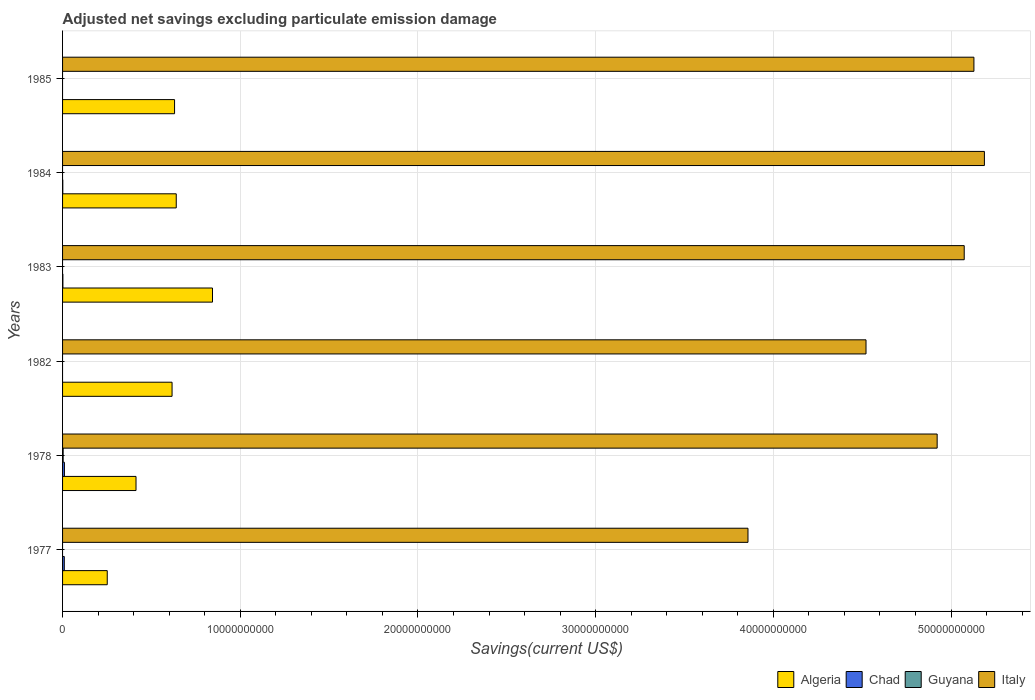How many different coloured bars are there?
Provide a succinct answer. 4. Are the number of bars per tick equal to the number of legend labels?
Provide a short and direct response. No. Are the number of bars on each tick of the Y-axis equal?
Ensure brevity in your answer.  No. How many bars are there on the 2nd tick from the top?
Offer a very short reply. 3. What is the adjusted net savings in Chad in 1984?
Ensure brevity in your answer.  1.26e+07. Across all years, what is the maximum adjusted net savings in Chad?
Keep it short and to the point. 1.05e+08. Across all years, what is the minimum adjusted net savings in Algeria?
Keep it short and to the point. 2.51e+09. In which year was the adjusted net savings in Italy maximum?
Make the answer very short. 1984. What is the total adjusted net savings in Chad in the graph?
Your answer should be very brief. 2.33e+08. What is the difference between the adjusted net savings in Italy in 1983 and that in 1984?
Your response must be concise. -1.14e+09. What is the difference between the adjusted net savings in Italy in 1978 and the adjusted net savings in Guyana in 1985?
Keep it short and to the point. 4.92e+1. What is the average adjusted net savings in Guyana per year?
Make the answer very short. 5.49e+06. In the year 1978, what is the difference between the adjusted net savings in Guyana and adjusted net savings in Italy?
Your answer should be compact. -4.92e+1. In how many years, is the adjusted net savings in Italy greater than 4000000000 US$?
Provide a short and direct response. 6. What is the ratio of the adjusted net savings in Italy in 1983 to that in 1984?
Provide a succinct answer. 0.98. What is the difference between the highest and the second highest adjusted net savings in Italy?
Keep it short and to the point. 5.90e+08. What is the difference between the highest and the lowest adjusted net savings in Algeria?
Offer a very short reply. 5.92e+09. Is the sum of the adjusted net savings in Chad in 1978 and 1984 greater than the maximum adjusted net savings in Italy across all years?
Keep it short and to the point. No. What is the difference between two consecutive major ticks on the X-axis?
Offer a terse response. 1.00e+1. Are the values on the major ticks of X-axis written in scientific E-notation?
Offer a very short reply. No. Does the graph contain grids?
Keep it short and to the point. Yes. How many legend labels are there?
Offer a terse response. 4. How are the legend labels stacked?
Make the answer very short. Horizontal. What is the title of the graph?
Make the answer very short. Adjusted net savings excluding particulate emission damage. What is the label or title of the X-axis?
Offer a very short reply. Savings(current US$). What is the Savings(current US$) in Algeria in 1977?
Ensure brevity in your answer.  2.51e+09. What is the Savings(current US$) of Chad in 1977?
Your answer should be very brief. 9.73e+07. What is the Savings(current US$) of Guyana in 1977?
Offer a very short reply. 0. What is the Savings(current US$) in Italy in 1977?
Your answer should be compact. 3.86e+1. What is the Savings(current US$) in Algeria in 1978?
Give a very brief answer. 4.13e+09. What is the Savings(current US$) in Chad in 1978?
Offer a very short reply. 1.05e+08. What is the Savings(current US$) of Guyana in 1978?
Keep it short and to the point. 3.29e+07. What is the Savings(current US$) of Italy in 1978?
Your response must be concise. 4.92e+1. What is the Savings(current US$) in Algeria in 1982?
Offer a terse response. 6.16e+09. What is the Savings(current US$) in Chad in 1982?
Your answer should be very brief. 0. What is the Savings(current US$) of Guyana in 1982?
Make the answer very short. 0. What is the Savings(current US$) of Italy in 1982?
Your response must be concise. 4.52e+1. What is the Savings(current US$) of Algeria in 1983?
Provide a succinct answer. 8.44e+09. What is the Savings(current US$) of Chad in 1983?
Ensure brevity in your answer.  1.84e+07. What is the Savings(current US$) in Italy in 1983?
Give a very brief answer. 5.07e+1. What is the Savings(current US$) of Algeria in 1984?
Offer a very short reply. 6.40e+09. What is the Savings(current US$) of Chad in 1984?
Offer a terse response. 1.26e+07. What is the Savings(current US$) of Guyana in 1984?
Your answer should be compact. 0. What is the Savings(current US$) in Italy in 1984?
Your response must be concise. 5.19e+1. What is the Savings(current US$) in Algeria in 1985?
Provide a short and direct response. 6.30e+09. What is the Savings(current US$) in Italy in 1985?
Ensure brevity in your answer.  5.13e+1. Across all years, what is the maximum Savings(current US$) in Algeria?
Ensure brevity in your answer.  8.44e+09. Across all years, what is the maximum Savings(current US$) of Chad?
Offer a terse response. 1.05e+08. Across all years, what is the maximum Savings(current US$) in Guyana?
Provide a succinct answer. 3.29e+07. Across all years, what is the maximum Savings(current US$) in Italy?
Ensure brevity in your answer.  5.19e+1. Across all years, what is the minimum Savings(current US$) of Algeria?
Provide a succinct answer. 2.51e+09. Across all years, what is the minimum Savings(current US$) of Italy?
Offer a terse response. 3.86e+1. What is the total Savings(current US$) of Algeria in the graph?
Offer a very short reply. 3.39e+1. What is the total Savings(current US$) of Chad in the graph?
Provide a succinct answer. 2.33e+08. What is the total Savings(current US$) in Guyana in the graph?
Keep it short and to the point. 3.29e+07. What is the total Savings(current US$) in Italy in the graph?
Your answer should be compact. 2.87e+11. What is the difference between the Savings(current US$) in Algeria in 1977 and that in 1978?
Your response must be concise. -1.62e+09. What is the difference between the Savings(current US$) of Chad in 1977 and that in 1978?
Your answer should be very brief. -7.54e+06. What is the difference between the Savings(current US$) of Italy in 1977 and that in 1978?
Offer a very short reply. -1.06e+1. What is the difference between the Savings(current US$) in Algeria in 1977 and that in 1982?
Your response must be concise. -3.65e+09. What is the difference between the Savings(current US$) of Italy in 1977 and that in 1982?
Provide a succinct answer. -6.64e+09. What is the difference between the Savings(current US$) of Algeria in 1977 and that in 1983?
Make the answer very short. -5.92e+09. What is the difference between the Savings(current US$) of Chad in 1977 and that in 1983?
Provide a short and direct response. 7.90e+07. What is the difference between the Savings(current US$) of Italy in 1977 and that in 1983?
Offer a very short reply. -1.22e+1. What is the difference between the Savings(current US$) of Algeria in 1977 and that in 1984?
Ensure brevity in your answer.  -3.88e+09. What is the difference between the Savings(current US$) of Chad in 1977 and that in 1984?
Ensure brevity in your answer.  8.47e+07. What is the difference between the Savings(current US$) in Italy in 1977 and that in 1984?
Your response must be concise. -1.33e+1. What is the difference between the Savings(current US$) of Algeria in 1977 and that in 1985?
Offer a very short reply. -3.79e+09. What is the difference between the Savings(current US$) of Italy in 1977 and that in 1985?
Provide a short and direct response. -1.27e+1. What is the difference between the Savings(current US$) in Algeria in 1978 and that in 1982?
Provide a succinct answer. -2.03e+09. What is the difference between the Savings(current US$) of Italy in 1978 and that in 1982?
Give a very brief answer. 4.00e+09. What is the difference between the Savings(current US$) of Algeria in 1978 and that in 1983?
Offer a terse response. -4.30e+09. What is the difference between the Savings(current US$) in Chad in 1978 and that in 1983?
Make the answer very short. 8.65e+07. What is the difference between the Savings(current US$) in Italy in 1978 and that in 1983?
Your answer should be very brief. -1.52e+09. What is the difference between the Savings(current US$) in Algeria in 1978 and that in 1984?
Provide a succinct answer. -2.26e+09. What is the difference between the Savings(current US$) in Chad in 1978 and that in 1984?
Offer a terse response. 9.23e+07. What is the difference between the Savings(current US$) in Italy in 1978 and that in 1984?
Provide a succinct answer. -2.66e+09. What is the difference between the Savings(current US$) in Algeria in 1978 and that in 1985?
Give a very brief answer. -2.17e+09. What is the difference between the Savings(current US$) of Italy in 1978 and that in 1985?
Your response must be concise. -2.07e+09. What is the difference between the Savings(current US$) in Algeria in 1982 and that in 1983?
Ensure brevity in your answer.  -2.28e+09. What is the difference between the Savings(current US$) in Italy in 1982 and that in 1983?
Offer a very short reply. -5.53e+09. What is the difference between the Savings(current US$) of Algeria in 1982 and that in 1984?
Keep it short and to the point. -2.36e+08. What is the difference between the Savings(current US$) of Italy in 1982 and that in 1984?
Your answer should be very brief. -6.66e+09. What is the difference between the Savings(current US$) of Algeria in 1982 and that in 1985?
Your answer should be compact. -1.40e+08. What is the difference between the Savings(current US$) in Italy in 1982 and that in 1985?
Your answer should be very brief. -6.07e+09. What is the difference between the Savings(current US$) of Algeria in 1983 and that in 1984?
Provide a short and direct response. 2.04e+09. What is the difference between the Savings(current US$) in Chad in 1983 and that in 1984?
Provide a short and direct response. 5.76e+06. What is the difference between the Savings(current US$) of Italy in 1983 and that in 1984?
Offer a terse response. -1.14e+09. What is the difference between the Savings(current US$) in Algeria in 1983 and that in 1985?
Your answer should be compact. 2.14e+09. What is the difference between the Savings(current US$) of Italy in 1983 and that in 1985?
Make the answer very short. -5.46e+08. What is the difference between the Savings(current US$) in Algeria in 1984 and that in 1985?
Your answer should be very brief. 9.57e+07. What is the difference between the Savings(current US$) of Italy in 1984 and that in 1985?
Offer a terse response. 5.90e+08. What is the difference between the Savings(current US$) in Algeria in 1977 and the Savings(current US$) in Chad in 1978?
Give a very brief answer. 2.41e+09. What is the difference between the Savings(current US$) in Algeria in 1977 and the Savings(current US$) in Guyana in 1978?
Give a very brief answer. 2.48e+09. What is the difference between the Savings(current US$) of Algeria in 1977 and the Savings(current US$) of Italy in 1978?
Ensure brevity in your answer.  -4.67e+1. What is the difference between the Savings(current US$) in Chad in 1977 and the Savings(current US$) in Guyana in 1978?
Keep it short and to the point. 6.44e+07. What is the difference between the Savings(current US$) in Chad in 1977 and the Savings(current US$) in Italy in 1978?
Keep it short and to the point. -4.91e+1. What is the difference between the Savings(current US$) of Algeria in 1977 and the Savings(current US$) of Italy in 1982?
Offer a terse response. -4.27e+1. What is the difference between the Savings(current US$) in Chad in 1977 and the Savings(current US$) in Italy in 1982?
Offer a terse response. -4.51e+1. What is the difference between the Savings(current US$) of Algeria in 1977 and the Savings(current US$) of Chad in 1983?
Provide a short and direct response. 2.50e+09. What is the difference between the Savings(current US$) of Algeria in 1977 and the Savings(current US$) of Italy in 1983?
Your answer should be compact. -4.82e+1. What is the difference between the Savings(current US$) of Chad in 1977 and the Savings(current US$) of Italy in 1983?
Give a very brief answer. -5.06e+1. What is the difference between the Savings(current US$) of Algeria in 1977 and the Savings(current US$) of Chad in 1984?
Provide a short and direct response. 2.50e+09. What is the difference between the Savings(current US$) in Algeria in 1977 and the Savings(current US$) in Italy in 1984?
Your answer should be compact. -4.94e+1. What is the difference between the Savings(current US$) of Chad in 1977 and the Savings(current US$) of Italy in 1984?
Offer a very short reply. -5.18e+1. What is the difference between the Savings(current US$) of Algeria in 1977 and the Savings(current US$) of Italy in 1985?
Offer a very short reply. -4.88e+1. What is the difference between the Savings(current US$) in Chad in 1977 and the Savings(current US$) in Italy in 1985?
Give a very brief answer. -5.12e+1. What is the difference between the Savings(current US$) in Algeria in 1978 and the Savings(current US$) in Italy in 1982?
Provide a succinct answer. -4.11e+1. What is the difference between the Savings(current US$) of Chad in 1978 and the Savings(current US$) of Italy in 1982?
Offer a terse response. -4.51e+1. What is the difference between the Savings(current US$) of Guyana in 1978 and the Savings(current US$) of Italy in 1982?
Your answer should be compact. -4.52e+1. What is the difference between the Savings(current US$) in Algeria in 1978 and the Savings(current US$) in Chad in 1983?
Give a very brief answer. 4.11e+09. What is the difference between the Savings(current US$) of Algeria in 1978 and the Savings(current US$) of Italy in 1983?
Ensure brevity in your answer.  -4.66e+1. What is the difference between the Savings(current US$) of Chad in 1978 and the Savings(current US$) of Italy in 1983?
Make the answer very short. -5.06e+1. What is the difference between the Savings(current US$) of Guyana in 1978 and the Savings(current US$) of Italy in 1983?
Keep it short and to the point. -5.07e+1. What is the difference between the Savings(current US$) in Algeria in 1978 and the Savings(current US$) in Chad in 1984?
Ensure brevity in your answer.  4.12e+09. What is the difference between the Savings(current US$) in Algeria in 1978 and the Savings(current US$) in Italy in 1984?
Your answer should be compact. -4.77e+1. What is the difference between the Savings(current US$) of Chad in 1978 and the Savings(current US$) of Italy in 1984?
Provide a short and direct response. -5.18e+1. What is the difference between the Savings(current US$) of Guyana in 1978 and the Savings(current US$) of Italy in 1984?
Your response must be concise. -5.18e+1. What is the difference between the Savings(current US$) of Algeria in 1978 and the Savings(current US$) of Italy in 1985?
Your response must be concise. -4.72e+1. What is the difference between the Savings(current US$) of Chad in 1978 and the Savings(current US$) of Italy in 1985?
Make the answer very short. -5.12e+1. What is the difference between the Savings(current US$) of Guyana in 1978 and the Savings(current US$) of Italy in 1985?
Offer a very short reply. -5.13e+1. What is the difference between the Savings(current US$) of Algeria in 1982 and the Savings(current US$) of Chad in 1983?
Keep it short and to the point. 6.14e+09. What is the difference between the Savings(current US$) in Algeria in 1982 and the Savings(current US$) in Italy in 1983?
Offer a terse response. -4.46e+1. What is the difference between the Savings(current US$) in Algeria in 1982 and the Savings(current US$) in Chad in 1984?
Keep it short and to the point. 6.15e+09. What is the difference between the Savings(current US$) in Algeria in 1982 and the Savings(current US$) in Italy in 1984?
Your answer should be compact. -4.57e+1. What is the difference between the Savings(current US$) in Algeria in 1982 and the Savings(current US$) in Italy in 1985?
Make the answer very short. -4.51e+1. What is the difference between the Savings(current US$) of Algeria in 1983 and the Savings(current US$) of Chad in 1984?
Offer a terse response. 8.42e+09. What is the difference between the Savings(current US$) in Algeria in 1983 and the Savings(current US$) in Italy in 1984?
Your answer should be very brief. -4.34e+1. What is the difference between the Savings(current US$) of Chad in 1983 and the Savings(current US$) of Italy in 1984?
Provide a succinct answer. -5.19e+1. What is the difference between the Savings(current US$) in Algeria in 1983 and the Savings(current US$) in Italy in 1985?
Provide a succinct answer. -4.28e+1. What is the difference between the Savings(current US$) of Chad in 1983 and the Savings(current US$) of Italy in 1985?
Offer a terse response. -5.13e+1. What is the difference between the Savings(current US$) in Algeria in 1984 and the Savings(current US$) in Italy in 1985?
Ensure brevity in your answer.  -4.49e+1. What is the difference between the Savings(current US$) in Chad in 1984 and the Savings(current US$) in Italy in 1985?
Make the answer very short. -5.13e+1. What is the average Savings(current US$) in Algeria per year?
Provide a succinct answer. 5.66e+09. What is the average Savings(current US$) in Chad per year?
Provide a short and direct response. 3.89e+07. What is the average Savings(current US$) in Guyana per year?
Make the answer very short. 5.49e+06. What is the average Savings(current US$) of Italy per year?
Your answer should be very brief. 4.78e+1. In the year 1977, what is the difference between the Savings(current US$) of Algeria and Savings(current US$) of Chad?
Keep it short and to the point. 2.42e+09. In the year 1977, what is the difference between the Savings(current US$) in Algeria and Savings(current US$) in Italy?
Your answer should be very brief. -3.61e+1. In the year 1977, what is the difference between the Savings(current US$) in Chad and Savings(current US$) in Italy?
Your response must be concise. -3.85e+1. In the year 1978, what is the difference between the Savings(current US$) in Algeria and Savings(current US$) in Chad?
Provide a succinct answer. 4.03e+09. In the year 1978, what is the difference between the Savings(current US$) of Algeria and Savings(current US$) of Guyana?
Offer a terse response. 4.10e+09. In the year 1978, what is the difference between the Savings(current US$) of Algeria and Savings(current US$) of Italy?
Offer a terse response. -4.51e+1. In the year 1978, what is the difference between the Savings(current US$) in Chad and Savings(current US$) in Guyana?
Offer a very short reply. 7.19e+07. In the year 1978, what is the difference between the Savings(current US$) of Chad and Savings(current US$) of Italy?
Keep it short and to the point. -4.91e+1. In the year 1978, what is the difference between the Savings(current US$) of Guyana and Savings(current US$) of Italy?
Provide a short and direct response. -4.92e+1. In the year 1982, what is the difference between the Savings(current US$) in Algeria and Savings(current US$) in Italy?
Provide a short and direct response. -3.91e+1. In the year 1983, what is the difference between the Savings(current US$) of Algeria and Savings(current US$) of Chad?
Offer a terse response. 8.42e+09. In the year 1983, what is the difference between the Savings(current US$) in Algeria and Savings(current US$) in Italy?
Ensure brevity in your answer.  -4.23e+1. In the year 1983, what is the difference between the Savings(current US$) in Chad and Savings(current US$) in Italy?
Your response must be concise. -5.07e+1. In the year 1984, what is the difference between the Savings(current US$) in Algeria and Savings(current US$) in Chad?
Your answer should be compact. 6.39e+09. In the year 1984, what is the difference between the Savings(current US$) in Algeria and Savings(current US$) in Italy?
Your response must be concise. -4.55e+1. In the year 1984, what is the difference between the Savings(current US$) in Chad and Savings(current US$) in Italy?
Your response must be concise. -5.19e+1. In the year 1985, what is the difference between the Savings(current US$) in Algeria and Savings(current US$) in Italy?
Your answer should be very brief. -4.50e+1. What is the ratio of the Savings(current US$) in Algeria in 1977 to that in 1978?
Offer a terse response. 0.61. What is the ratio of the Savings(current US$) of Chad in 1977 to that in 1978?
Offer a terse response. 0.93. What is the ratio of the Savings(current US$) of Italy in 1977 to that in 1978?
Provide a short and direct response. 0.78. What is the ratio of the Savings(current US$) in Algeria in 1977 to that in 1982?
Your answer should be compact. 0.41. What is the ratio of the Savings(current US$) in Italy in 1977 to that in 1982?
Provide a succinct answer. 0.85. What is the ratio of the Savings(current US$) of Algeria in 1977 to that in 1983?
Offer a terse response. 0.3. What is the ratio of the Savings(current US$) of Chad in 1977 to that in 1983?
Provide a succinct answer. 5.3. What is the ratio of the Savings(current US$) in Italy in 1977 to that in 1983?
Offer a terse response. 0.76. What is the ratio of the Savings(current US$) of Algeria in 1977 to that in 1984?
Offer a terse response. 0.39. What is the ratio of the Savings(current US$) of Chad in 1977 to that in 1984?
Your response must be concise. 7.73. What is the ratio of the Savings(current US$) in Italy in 1977 to that in 1984?
Provide a short and direct response. 0.74. What is the ratio of the Savings(current US$) of Algeria in 1977 to that in 1985?
Offer a terse response. 0.4. What is the ratio of the Savings(current US$) in Italy in 1977 to that in 1985?
Ensure brevity in your answer.  0.75. What is the ratio of the Savings(current US$) in Algeria in 1978 to that in 1982?
Your answer should be compact. 0.67. What is the ratio of the Savings(current US$) in Italy in 1978 to that in 1982?
Provide a succinct answer. 1.09. What is the ratio of the Savings(current US$) in Algeria in 1978 to that in 1983?
Provide a succinct answer. 0.49. What is the ratio of the Savings(current US$) in Chad in 1978 to that in 1983?
Ensure brevity in your answer.  5.71. What is the ratio of the Savings(current US$) of Algeria in 1978 to that in 1984?
Your answer should be very brief. 0.65. What is the ratio of the Savings(current US$) of Chad in 1978 to that in 1984?
Provide a succinct answer. 8.33. What is the ratio of the Savings(current US$) of Italy in 1978 to that in 1984?
Give a very brief answer. 0.95. What is the ratio of the Savings(current US$) of Algeria in 1978 to that in 1985?
Your answer should be very brief. 0.66. What is the ratio of the Savings(current US$) of Italy in 1978 to that in 1985?
Your response must be concise. 0.96. What is the ratio of the Savings(current US$) of Algeria in 1982 to that in 1983?
Make the answer very short. 0.73. What is the ratio of the Savings(current US$) in Italy in 1982 to that in 1983?
Offer a terse response. 0.89. What is the ratio of the Savings(current US$) of Algeria in 1982 to that in 1984?
Offer a terse response. 0.96. What is the ratio of the Savings(current US$) of Italy in 1982 to that in 1984?
Your answer should be compact. 0.87. What is the ratio of the Savings(current US$) in Algeria in 1982 to that in 1985?
Give a very brief answer. 0.98. What is the ratio of the Savings(current US$) of Italy in 1982 to that in 1985?
Provide a succinct answer. 0.88. What is the ratio of the Savings(current US$) of Algeria in 1983 to that in 1984?
Your response must be concise. 1.32. What is the ratio of the Savings(current US$) in Chad in 1983 to that in 1984?
Your response must be concise. 1.46. What is the ratio of the Savings(current US$) in Italy in 1983 to that in 1984?
Offer a very short reply. 0.98. What is the ratio of the Savings(current US$) in Algeria in 1983 to that in 1985?
Provide a succinct answer. 1.34. What is the ratio of the Savings(current US$) in Algeria in 1984 to that in 1985?
Your response must be concise. 1.02. What is the ratio of the Savings(current US$) in Italy in 1984 to that in 1985?
Make the answer very short. 1.01. What is the difference between the highest and the second highest Savings(current US$) of Algeria?
Offer a terse response. 2.04e+09. What is the difference between the highest and the second highest Savings(current US$) of Chad?
Your answer should be very brief. 7.54e+06. What is the difference between the highest and the second highest Savings(current US$) in Italy?
Your answer should be compact. 5.90e+08. What is the difference between the highest and the lowest Savings(current US$) in Algeria?
Provide a short and direct response. 5.92e+09. What is the difference between the highest and the lowest Savings(current US$) of Chad?
Give a very brief answer. 1.05e+08. What is the difference between the highest and the lowest Savings(current US$) of Guyana?
Your answer should be compact. 3.29e+07. What is the difference between the highest and the lowest Savings(current US$) in Italy?
Ensure brevity in your answer.  1.33e+1. 